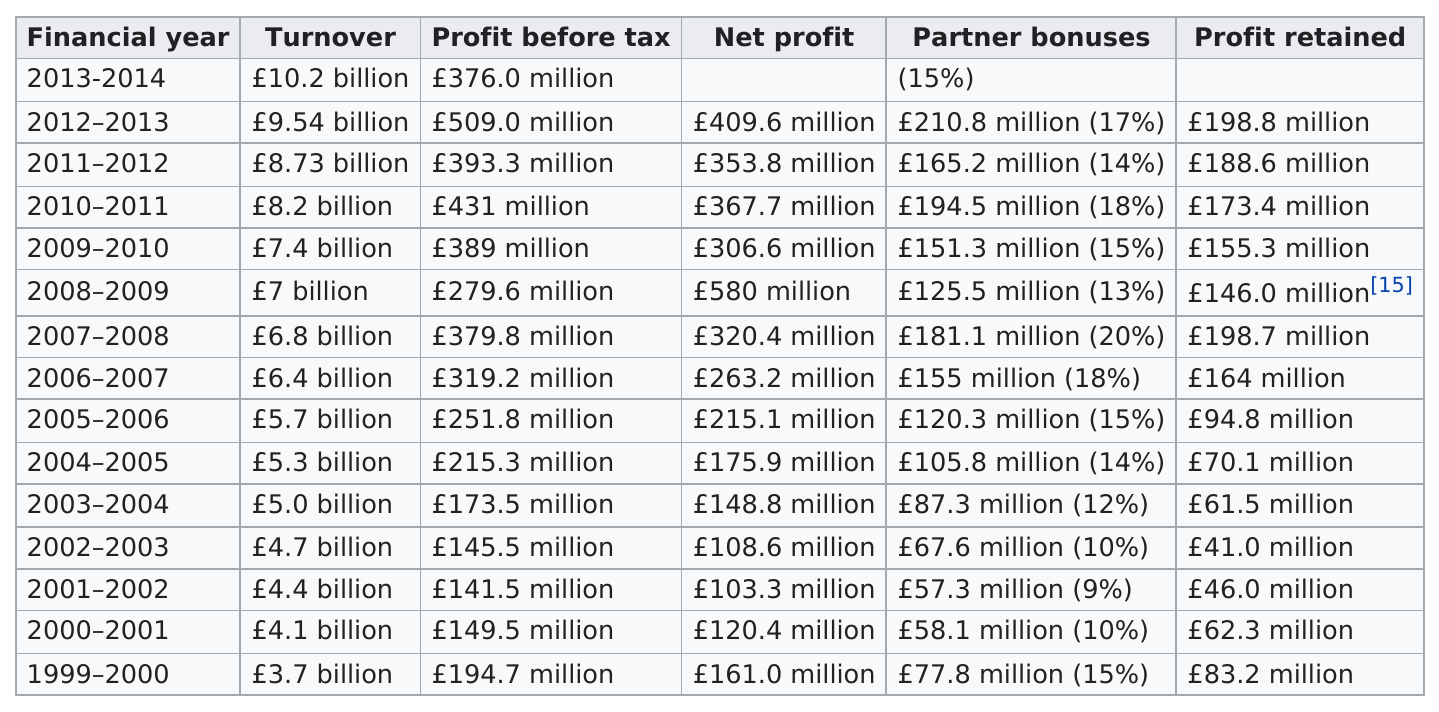Point out several critical features in this image. In the year 2012-2013, the most partner bonuses were earned. There are four turnovers that are below 5.0 billion. In the years 2001-2002, the company recorded the lowest net profit among all years. The first year in which Net Profit exceeded £120 million was 1999-2000. In the years 2008 and 2009, the best year for profit was recorded before 2010. 